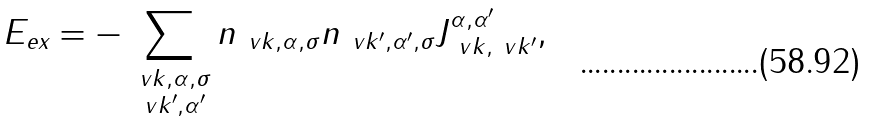<formula> <loc_0><loc_0><loc_500><loc_500>E _ { \text {ex} } = - \sum _ { \substack { \ v k , \alpha , \sigma \\ \ v k ^ { \prime } , \alpha ^ { \prime } } } n _ { \ v k , \alpha , \sigma } n _ { \ v k ^ { \prime } , \alpha ^ { \prime } , \sigma } J _ { \ v k , \ v k ^ { \prime } } ^ { \alpha , \alpha ^ { \prime } } ,</formula> 